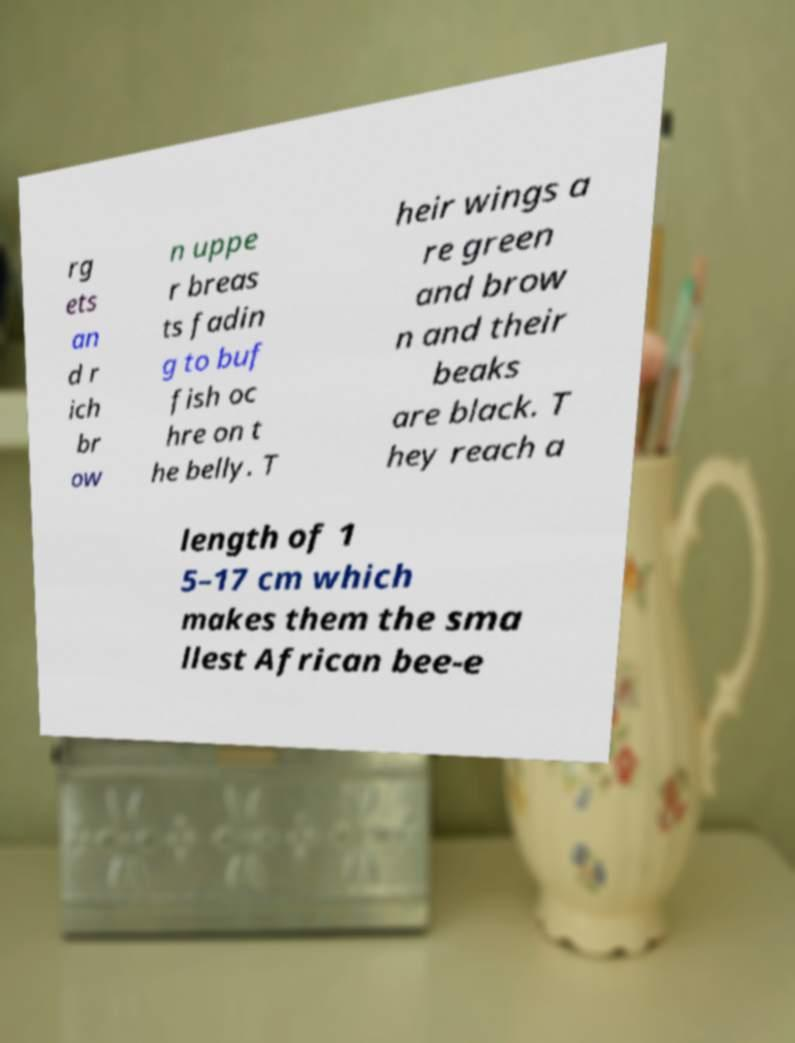Please identify and transcribe the text found in this image. rg ets an d r ich br ow n uppe r breas ts fadin g to buf fish oc hre on t he belly. T heir wings a re green and brow n and their beaks are black. T hey reach a length of 1 5–17 cm which makes them the sma llest African bee-e 